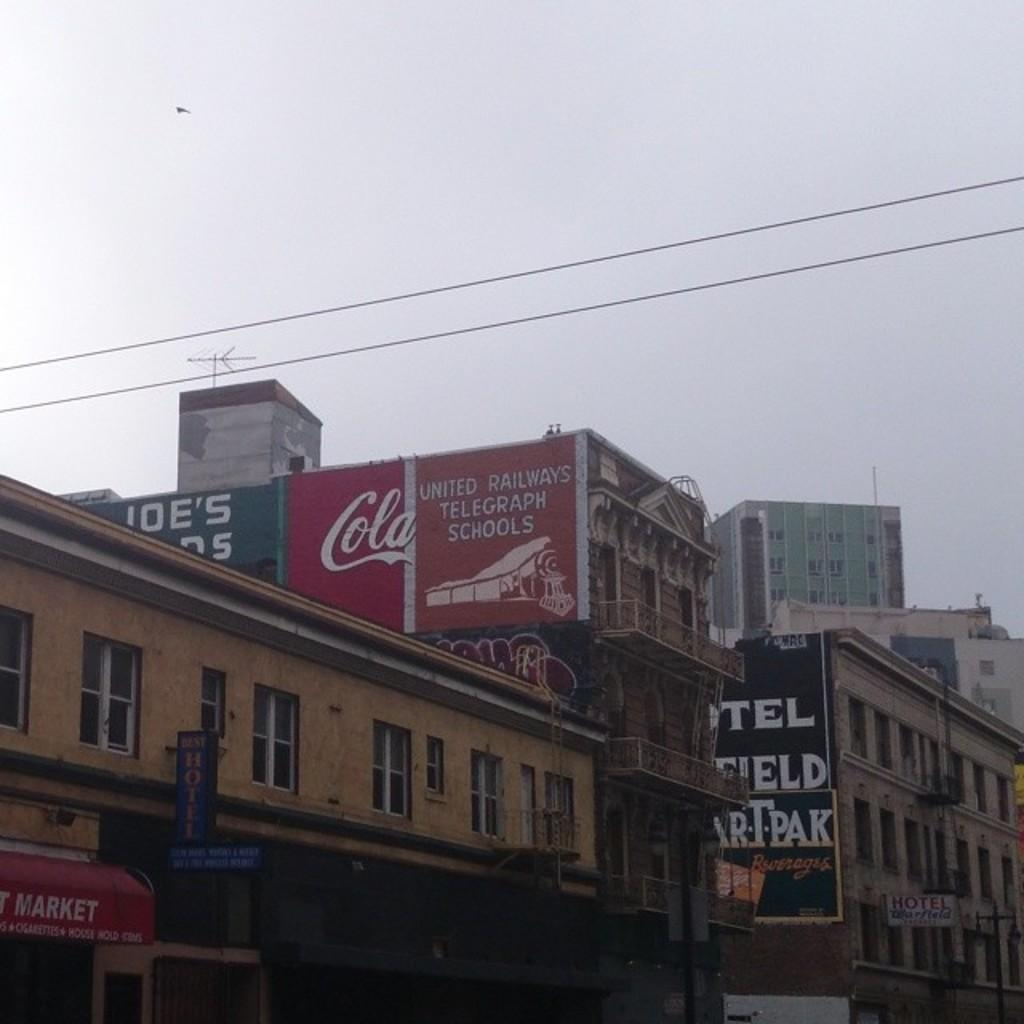<image>
Summarize the visual content of the image. a sign on the top of the building that says 'united railways telegraph schools' 